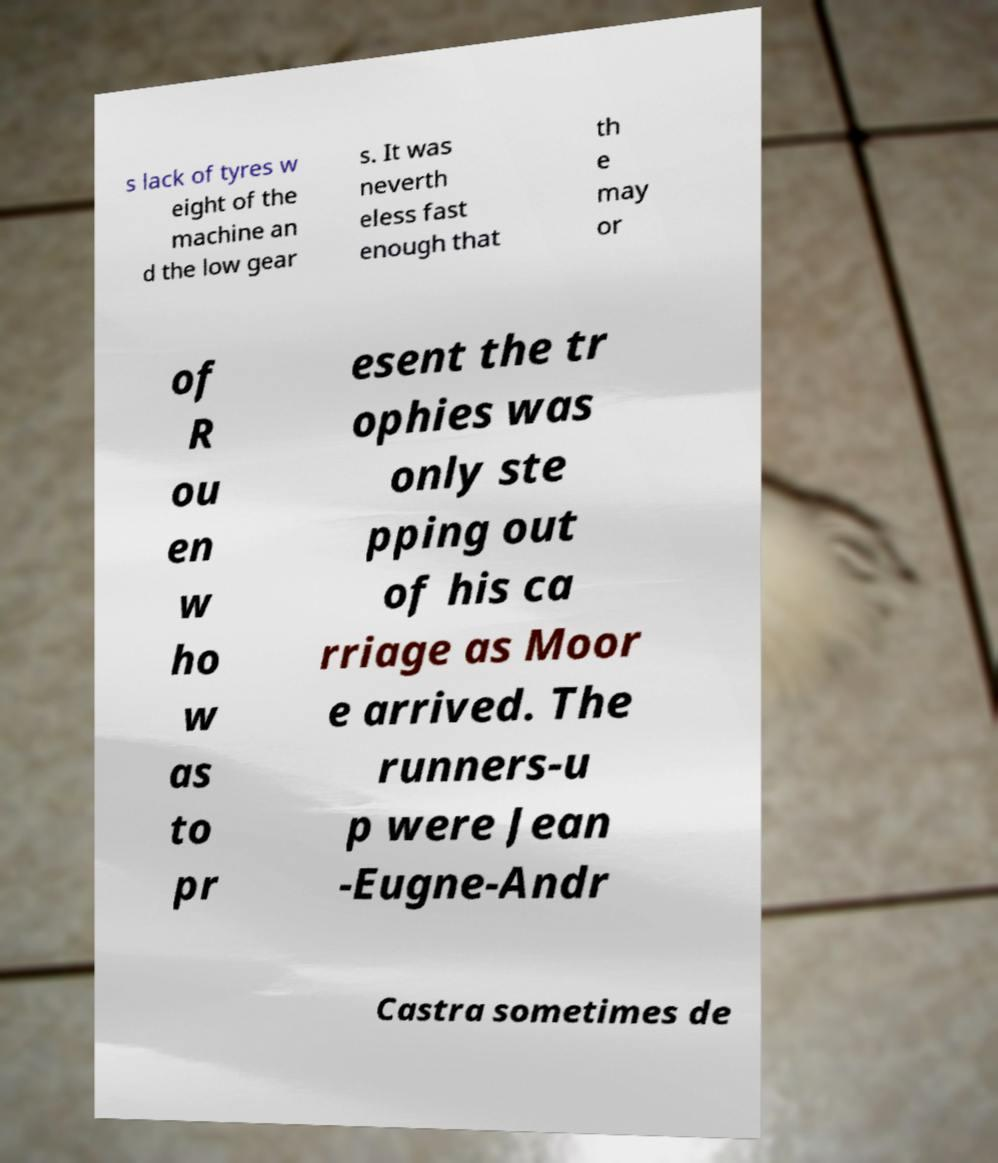I need the written content from this picture converted into text. Can you do that? s lack of tyres w eight of the machine an d the low gear s. It was neverth eless fast enough that th e may or of R ou en w ho w as to pr esent the tr ophies was only ste pping out of his ca rriage as Moor e arrived. The runners-u p were Jean -Eugne-Andr Castra sometimes de 